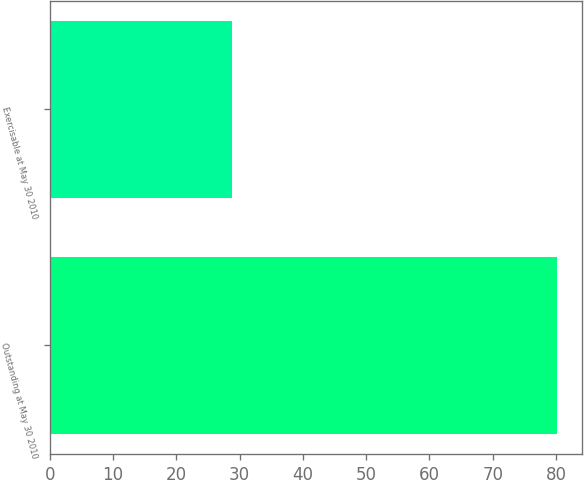Convert chart. <chart><loc_0><loc_0><loc_500><loc_500><bar_chart><fcel>Outstanding at May 30 2010<fcel>Exercisable at May 30 2010<nl><fcel>80.1<fcel>28.8<nl></chart> 